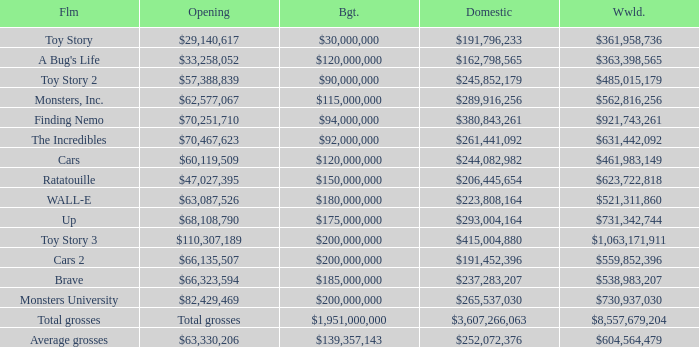Write the full table. {'header': ['Flm', 'Opening', 'Bgt.', 'Domestic', 'Wwld.'], 'rows': [['Toy Story', '$29,140,617', '$30,000,000', '$191,796,233', '$361,958,736'], ["A Bug's Life", '$33,258,052', '$120,000,000', '$162,798,565', '$363,398,565'], ['Toy Story 2', '$57,388,839', '$90,000,000', '$245,852,179', '$485,015,179'], ['Monsters, Inc.', '$62,577,067', '$115,000,000', '$289,916,256', '$562,816,256'], ['Finding Nemo', '$70,251,710', '$94,000,000', '$380,843,261', '$921,743,261'], ['The Incredibles', '$70,467,623', '$92,000,000', '$261,441,092', '$631,442,092'], ['Cars', '$60,119,509', '$120,000,000', '$244,082,982', '$461,983,149'], ['Ratatouille', '$47,027,395', '$150,000,000', '$206,445,654', '$623,722,818'], ['WALL-E', '$63,087,526', '$180,000,000', '$223,808,164', '$521,311,860'], ['Up', '$68,108,790', '$175,000,000', '$293,004,164', '$731,342,744'], ['Toy Story 3', '$110,307,189', '$200,000,000', '$415,004,880', '$1,063,171,911'], ['Cars 2', '$66,135,507', '$200,000,000', '$191,452,396', '$559,852,396'], ['Brave', '$66,323,594', '$185,000,000', '$237,283,207', '$538,983,207'], ['Monsters University', '$82,429,469', '$200,000,000', '$265,537,030', '$730,937,030'], ['Total grosses', 'Total grosses', '$1,951,000,000', '$3,607,266,063', '$8,557,679,204'], ['Average grosses', '$63,330,206', '$139,357,143', '$252,072,376', '$604,564,479']]} WHAT IS THE OPENING WITH A WORLDWIDE NUMBER OF $559,852,396? $66,135,507. 